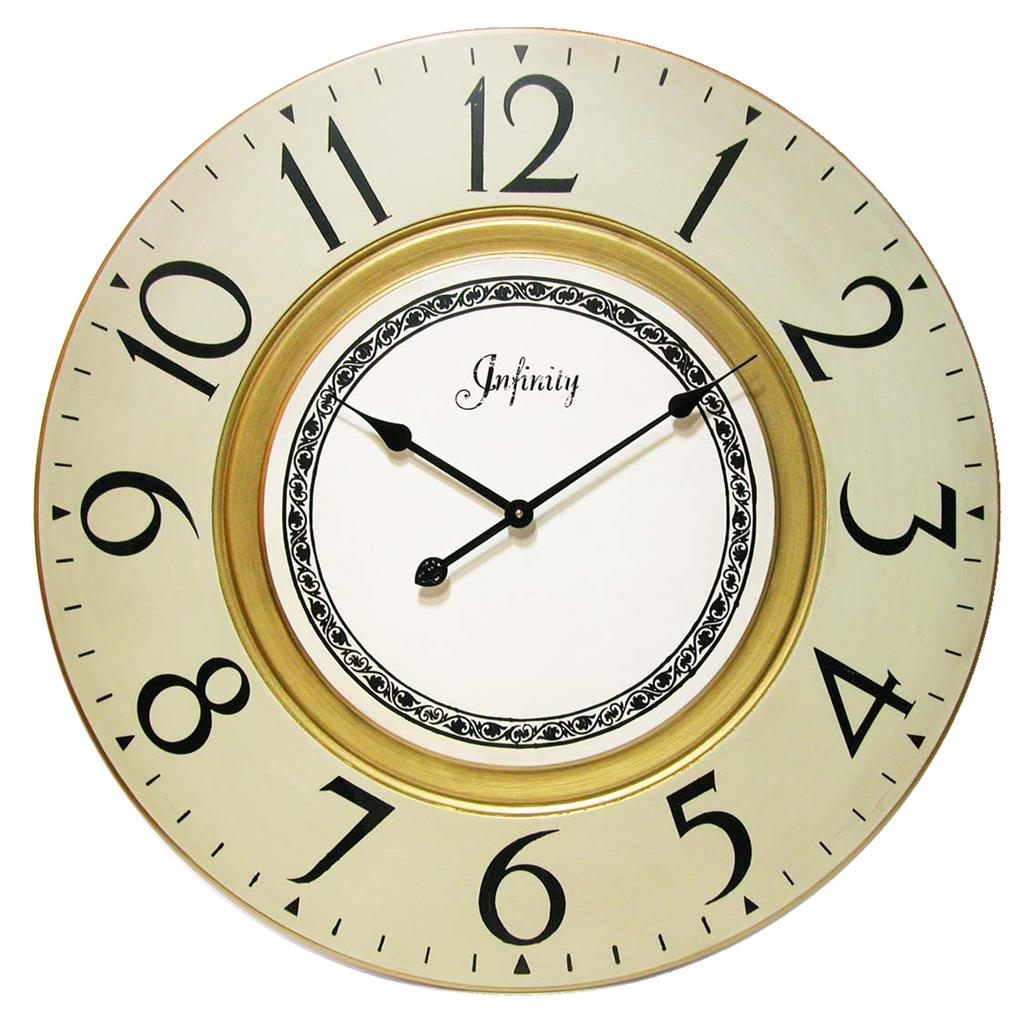Provide a one-sentence caption for the provided image. An Infinity clock says that the time is 10:09. 